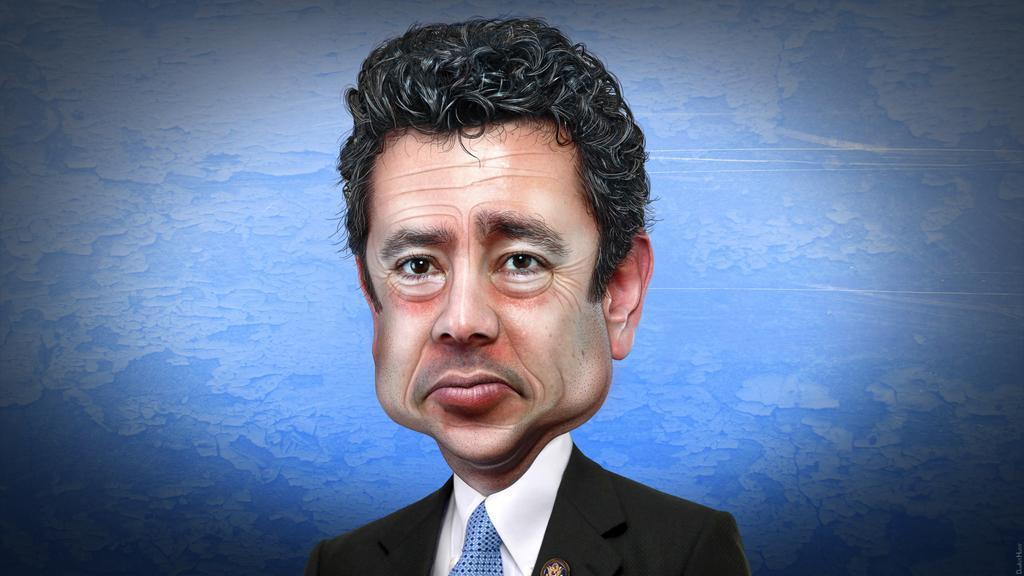How would you summarize this image in a sentence or two? In this picture we can see a man wore a blazer, tie and in the background it is blue color. 